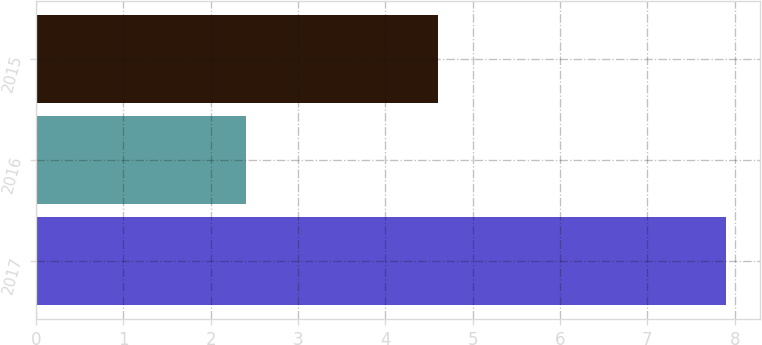Convert chart to OTSL. <chart><loc_0><loc_0><loc_500><loc_500><bar_chart><fcel>2017<fcel>2016<fcel>2015<nl><fcel>7.9<fcel>2.4<fcel>4.6<nl></chart> 